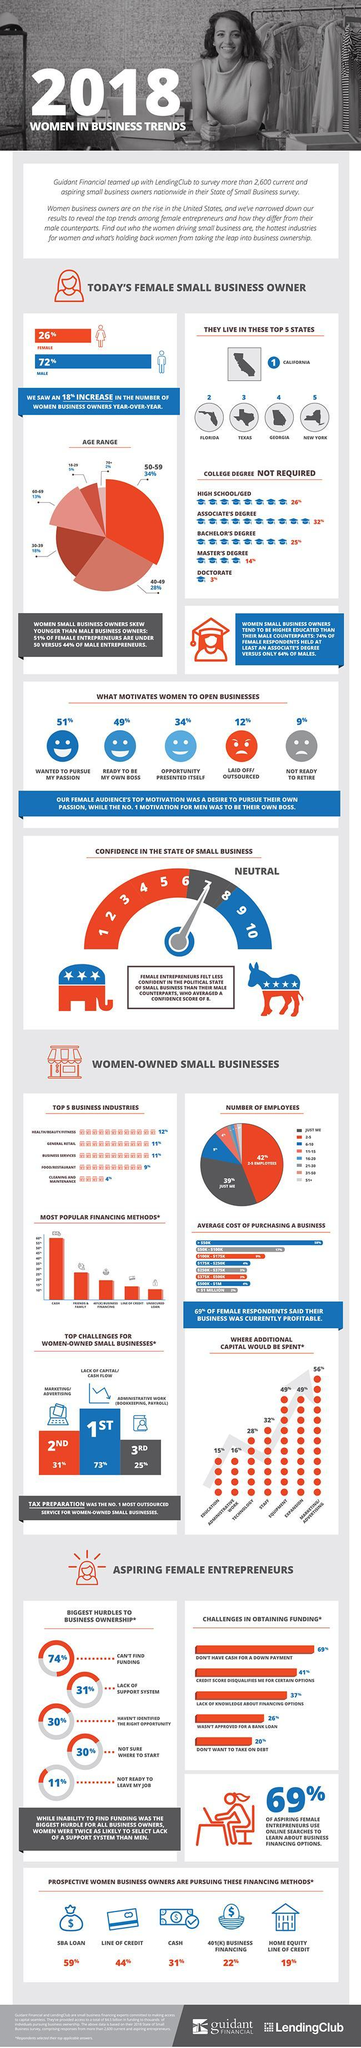What is the top challenge faced by 73% of women-owned small businesses?
Answer the question with a short phrase. Lack of capital/ cash flow What percent of women started a business because they were laid off? 12% What percent of women opened business to pursue their passion? 51% What challenge is faced by 31% of women-owned small businesses? Marketing/ Advertising 